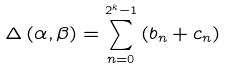Convert formula to latex. <formula><loc_0><loc_0><loc_500><loc_500>\Delta \left ( \alpha , \beta \right ) = \sum _ { n = 0 } ^ { 2 ^ { k } - 1 } \left ( b _ { n } + c _ { n } \right )</formula> 